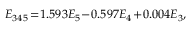Convert formula to latex. <formula><loc_0><loc_0><loc_500><loc_500>\begin{array} { r } { E _ { 3 4 5 } \, = \, 1 . 5 9 3 E _ { 5 } \, - \, 0 . 5 9 7 E _ { 4 } \, + \, 0 . 0 0 4 E _ { 3 } , } \end{array}</formula> 